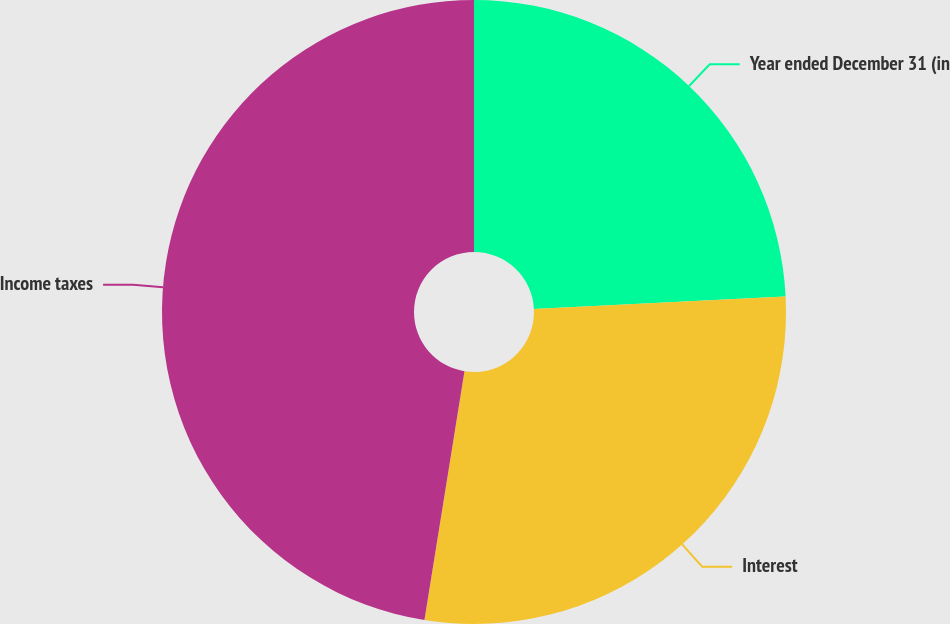Convert chart. <chart><loc_0><loc_0><loc_500><loc_500><pie_chart><fcel>Year ended December 31 (in<fcel>Interest<fcel>Income taxes<nl><fcel>24.21%<fcel>28.33%<fcel>47.46%<nl></chart> 